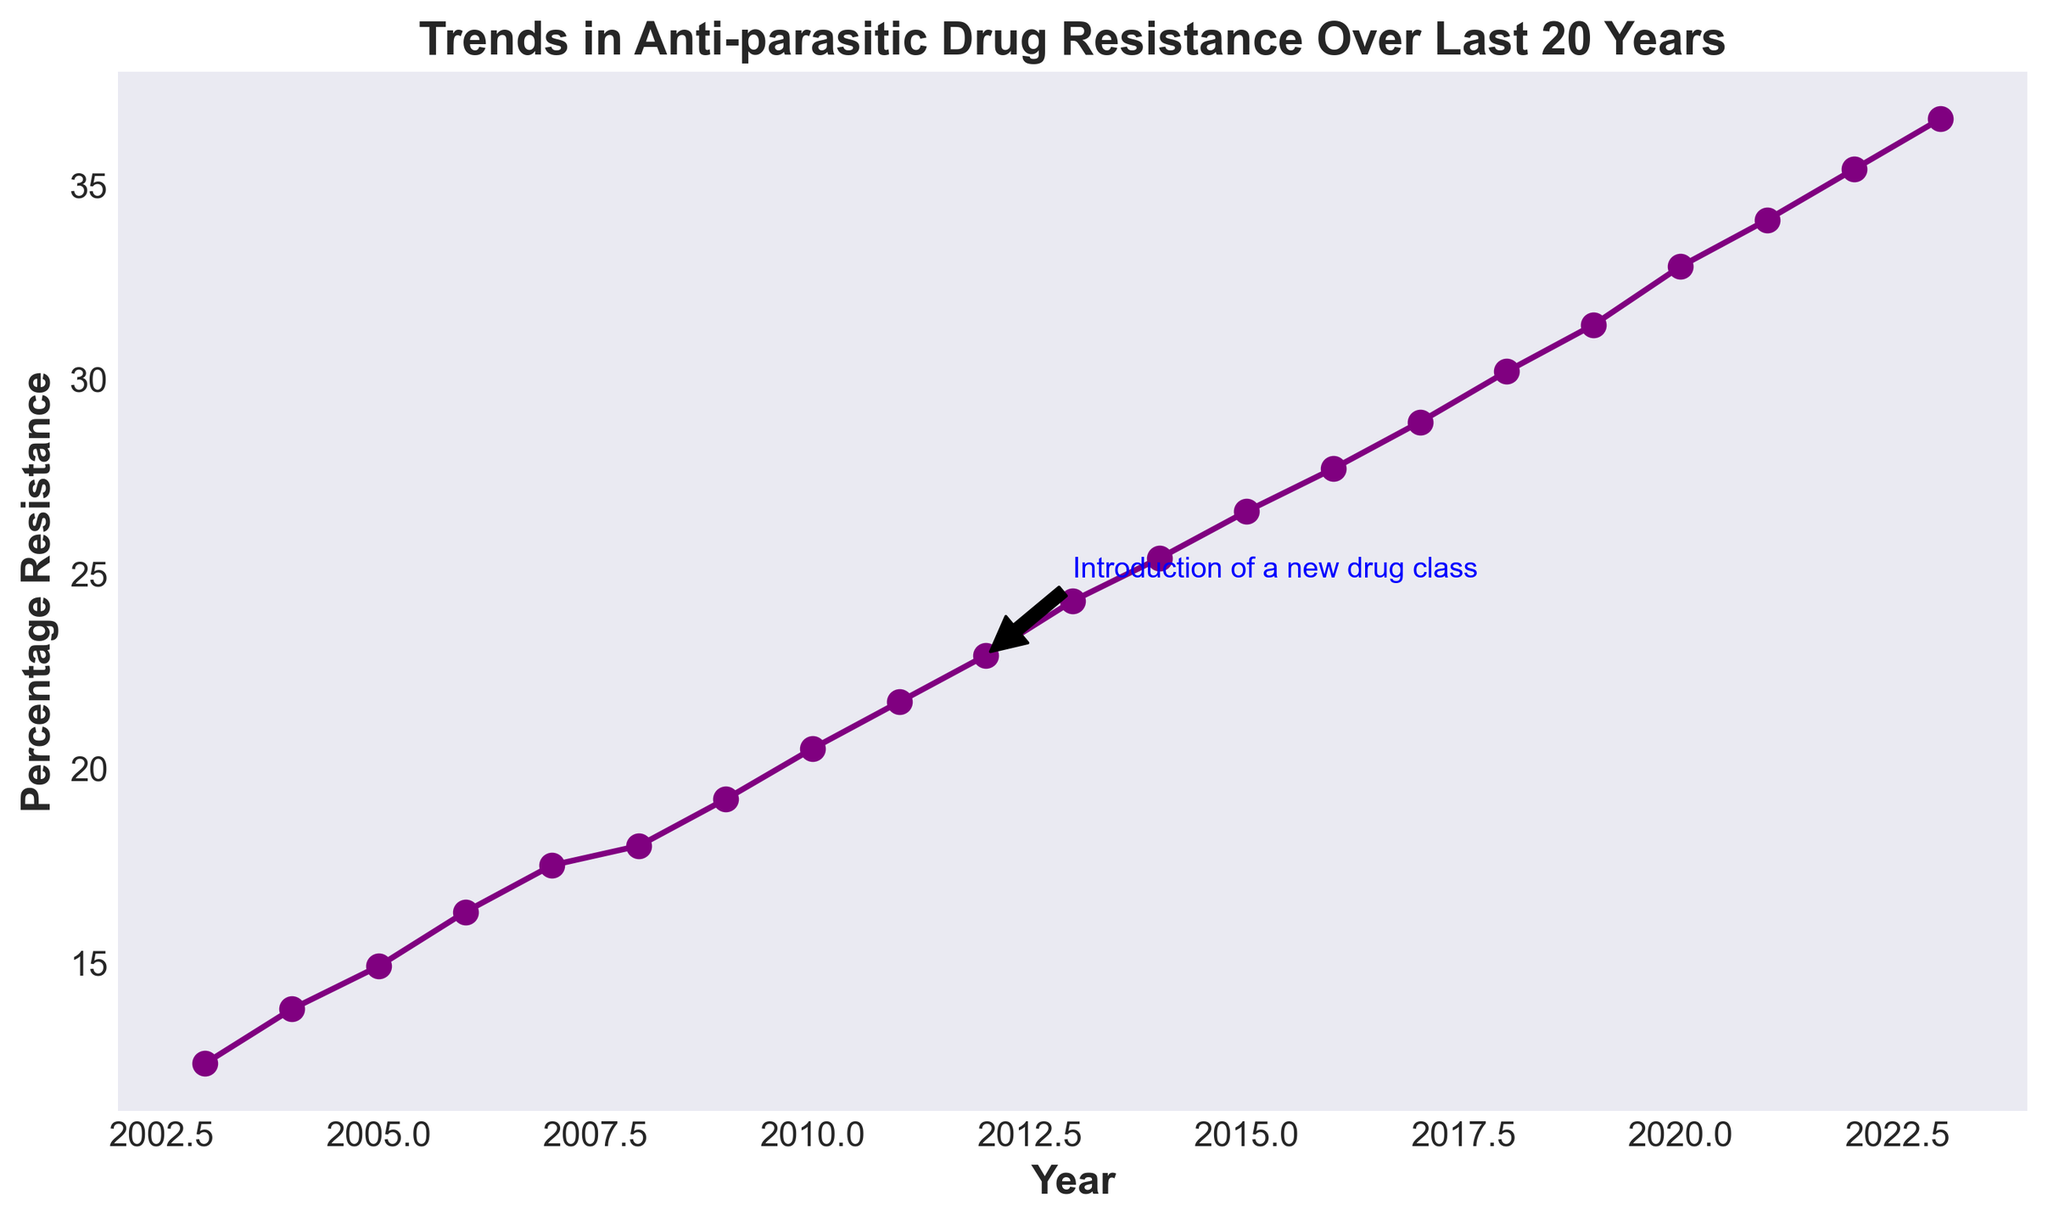What is the percentage resistance in the year 2015? The line chart shows the percentage resistance on the y-axis and the year on the x-axis. For 2015, trace the line horizontally from the year 2015 on the x-axis to where it intersects the line graph, then trace it vertically to the y-axis to find the percentage.
Answer: 26.6% How has the percentage resistance changed from 2012 to 2013 after the introduction of a new drug class? Locate 2012 and 2013 on the x-axis and find their corresponding percentage resistances on the y-axis. The percentage resistance in 2012 is annotated with "Introduction of a new drug class". Examine the difference between the two years.
Answer: Increased by 1.4% In which year did the percentage resistance first exceed 30%? Follow the line graph and find the first year where the percentage resistance surpasses the 30% mark on the y-axis.
Answer: 2018 Compare the percentage resistance between the years 2018 and 2022. Which year had a higher resistance? Identify the percentage resistance values for the years 2018 and 2022 from the line graph and compare the two values.
Answer: 2022 Estimate the average percentage resistance over the span from 2015 to 2020. Add the percentage resistances for the years 2015, 2016, 2017, 2018, 2019, and 2020, then divide by the number of years (6) to calculate the average.
Answer: 29.9% What is the trend in the percentage resistance from 2003 to 2023? Observe the overall direction of the line graph from 2003 to 2023.
Answer: Continuous increase What is the significance of the annotation in 2012? The annotation "Introduction of a new drug class" in 2012 points to a significant event that possibly impacted the trend in percentage resistance; observe if there's a noticeable change in the slope of the line graph around this year.
Answer: Introduction of a new drug class By how much did the percentage resistance increase from the start (2003) to the end (2023) of the study period? Subtract the percentage resistance in 2003 from that in 2023 to find the total increase over the 20-year period.
Answer: 24.3% During which year was there the largest single-year increase in percentage resistance? Calculate the difference in percentage resistance between each consecutive year and identify the maximum difference.
Answer: 2018 What is the color of the line representing the percentage resistance trend? Observe the color of the line used in the plot.
Answer: Purple 